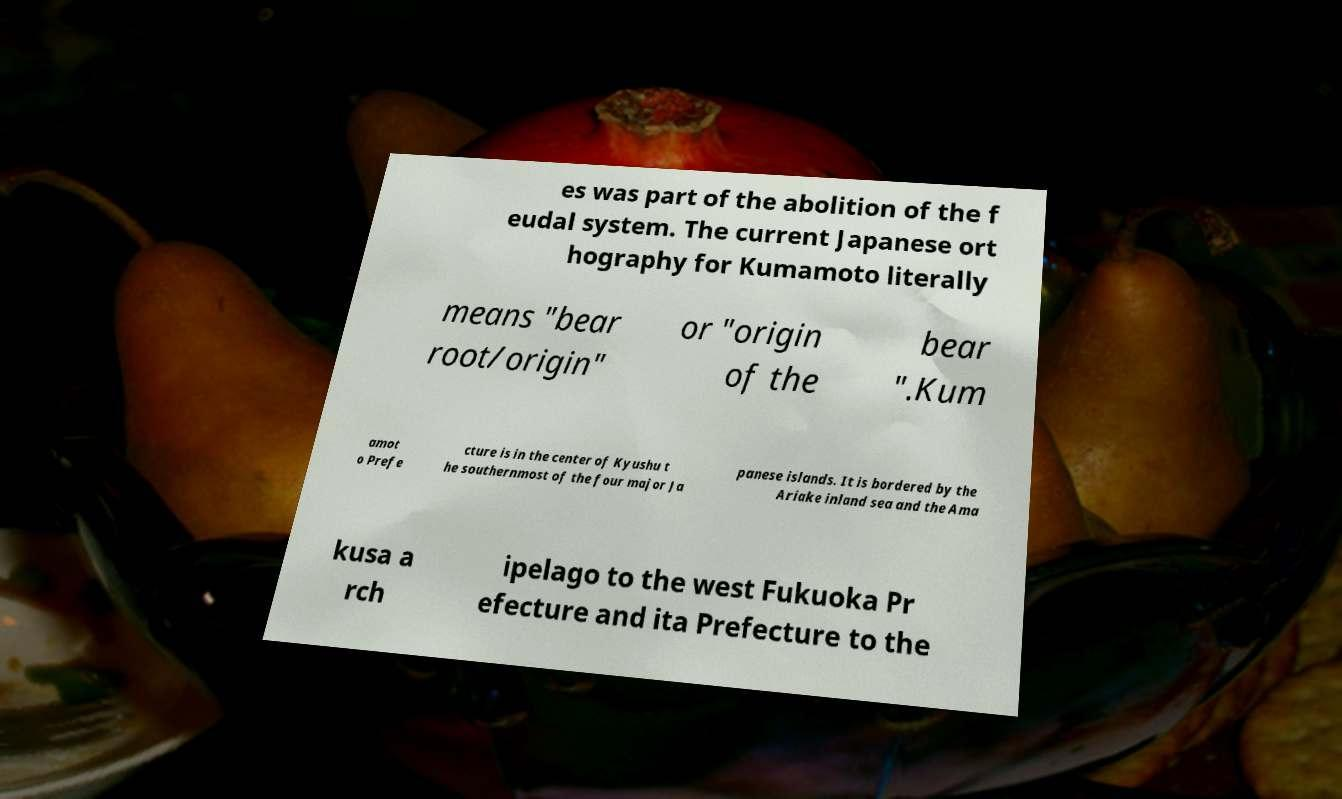For documentation purposes, I need the text within this image transcribed. Could you provide that? es was part of the abolition of the f eudal system. The current Japanese ort hography for Kumamoto literally means "bear root/origin" or "origin of the bear ".Kum amot o Prefe cture is in the center of Kyushu t he southernmost of the four major Ja panese islands. It is bordered by the Ariake inland sea and the Ama kusa a rch ipelago to the west Fukuoka Pr efecture and ita Prefecture to the 